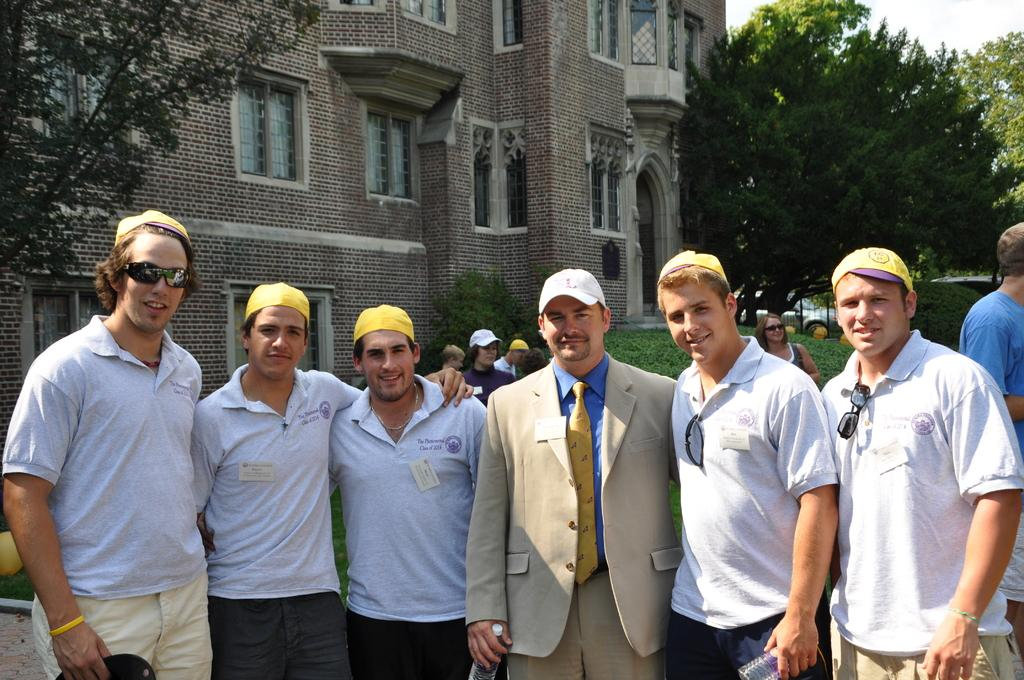How many people are in the image? There is a group of persons in the image. What are the people in the image doing? The persons are standing and smiling. What can be seen in the background of the image? There is a building, trees, persons, a car, and plants in the background of the image. What type of nest can be seen in the image? There is no nest present in the image. How many elbows are visible in the image? The image does not show any elbows, as it features a group of persons standing and smiling. 